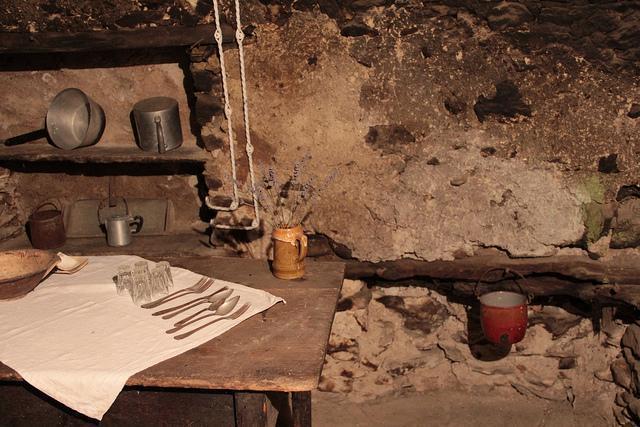How many cups can you see?
Give a very brief answer. 2. How many people are wearing red shirt?
Give a very brief answer. 0. 